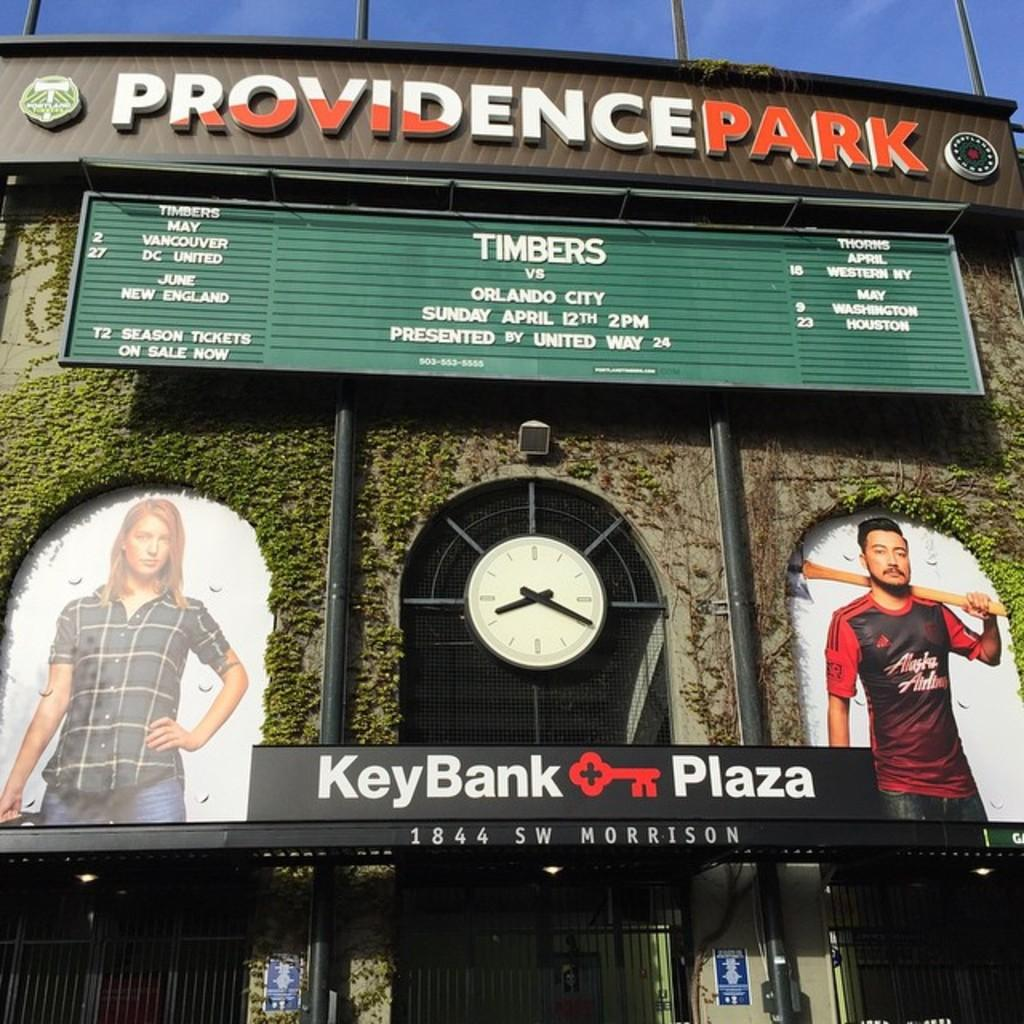Provide a one-sentence caption for the provided image. The facade of Providence Park stadium with a clock and a TImbers game. 